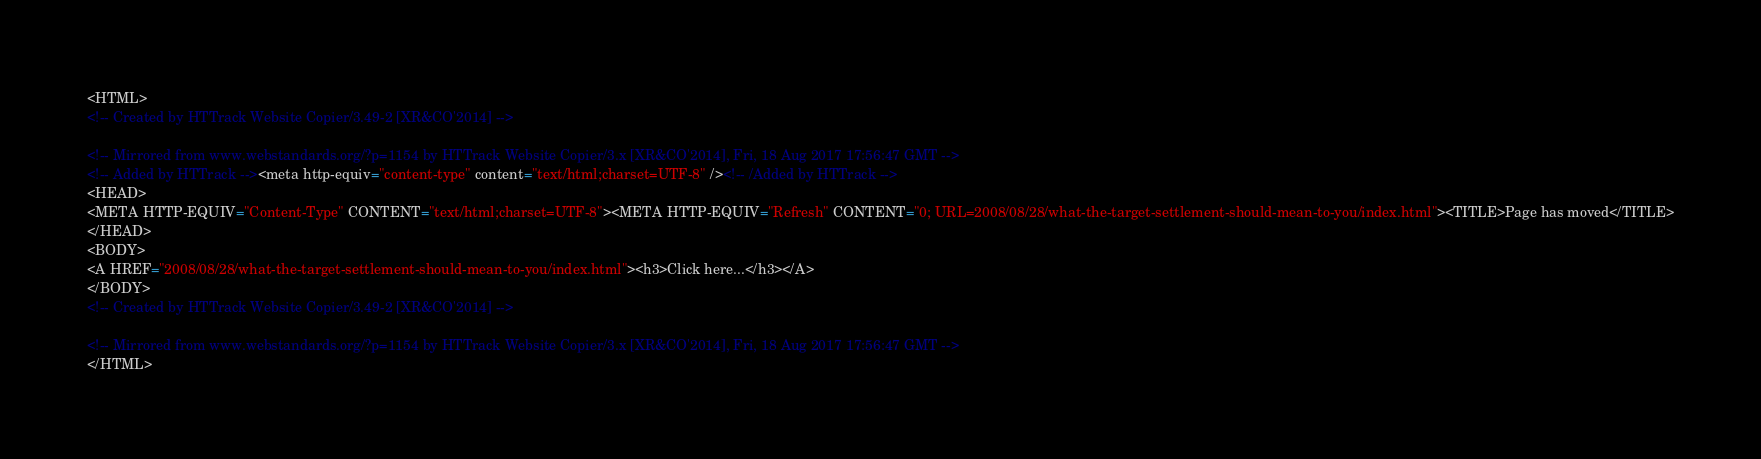<code> <loc_0><loc_0><loc_500><loc_500><_HTML_><HTML>
<!-- Created by HTTrack Website Copier/3.49-2 [XR&CO'2014] -->

<!-- Mirrored from www.webstandards.org/?p=1154 by HTTrack Website Copier/3.x [XR&CO'2014], Fri, 18 Aug 2017 17:56:47 GMT -->
<!-- Added by HTTrack --><meta http-equiv="content-type" content="text/html;charset=UTF-8" /><!-- /Added by HTTrack -->
<HEAD>
<META HTTP-EQUIV="Content-Type" CONTENT="text/html;charset=UTF-8"><META HTTP-EQUIV="Refresh" CONTENT="0; URL=2008/08/28/what-the-target-settlement-should-mean-to-you/index.html"><TITLE>Page has moved</TITLE>
</HEAD>
<BODY>
<A HREF="2008/08/28/what-the-target-settlement-should-mean-to-you/index.html"><h3>Click here...</h3></A>
</BODY>
<!-- Created by HTTrack Website Copier/3.49-2 [XR&CO'2014] -->

<!-- Mirrored from www.webstandards.org/?p=1154 by HTTrack Website Copier/3.x [XR&CO'2014], Fri, 18 Aug 2017 17:56:47 GMT -->
</HTML>
</code> 